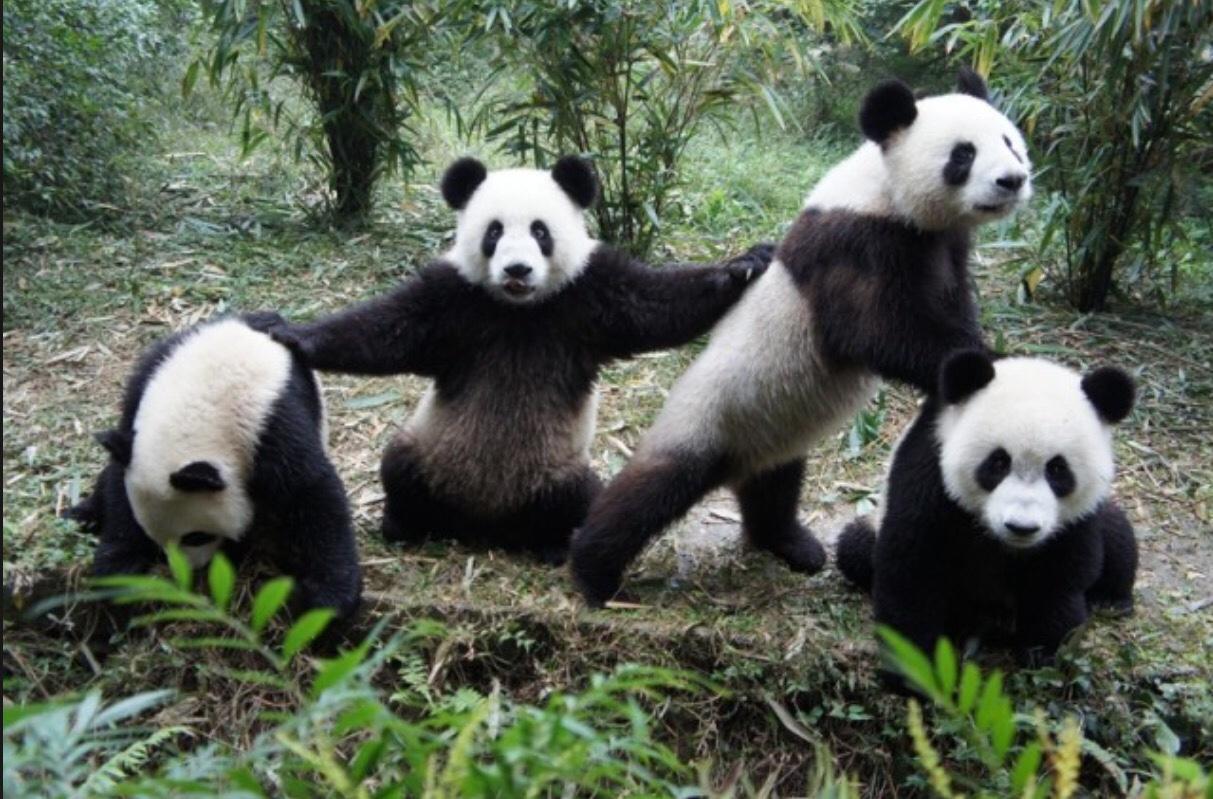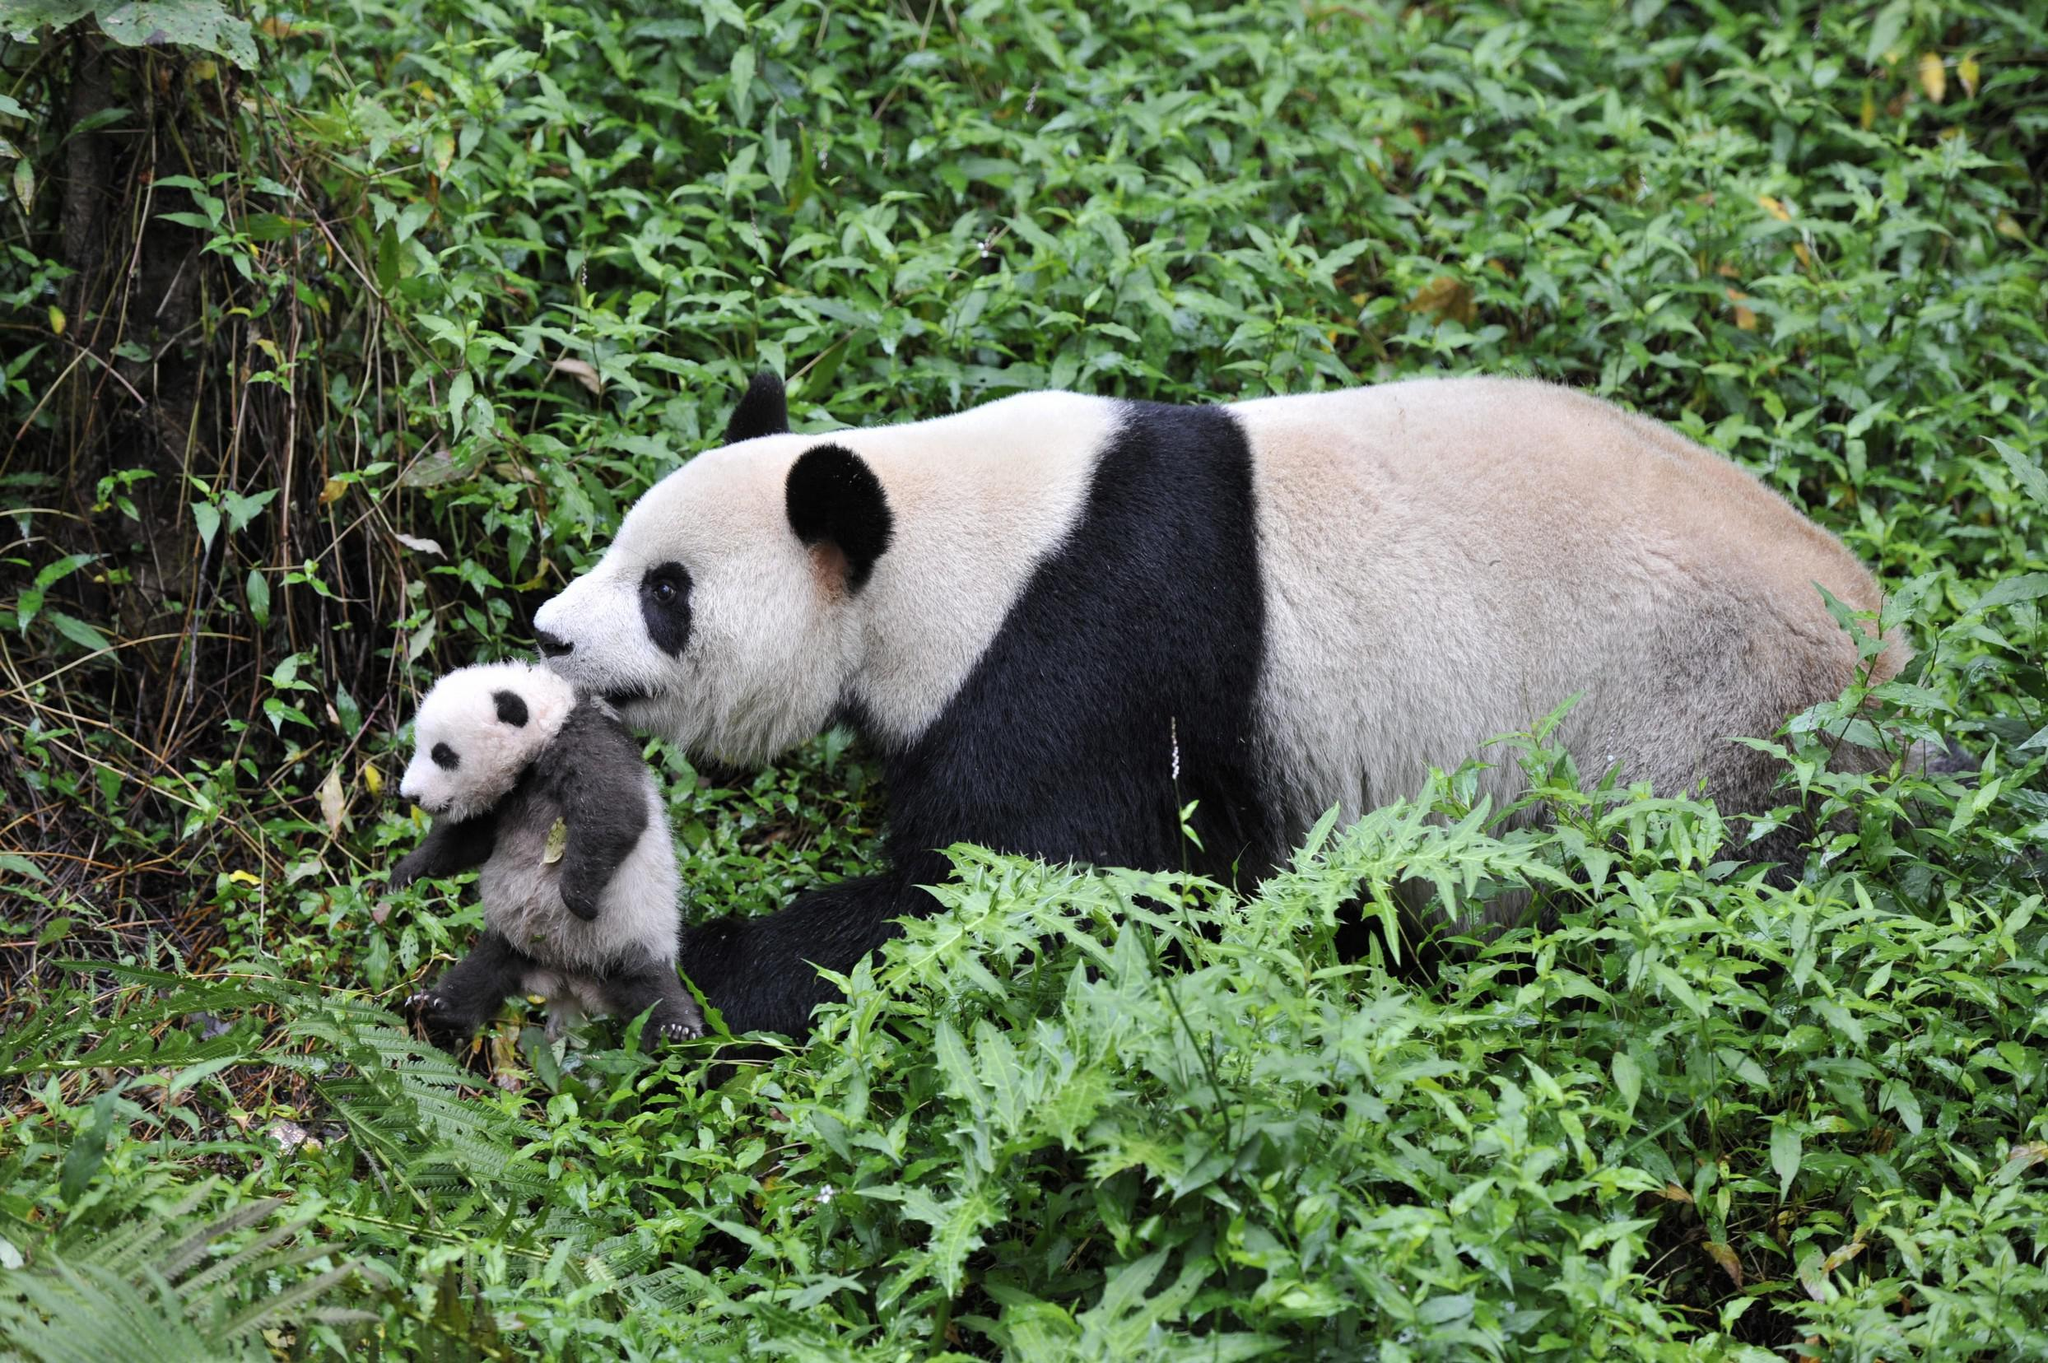The first image is the image on the left, the second image is the image on the right. Analyze the images presented: Is the assertion "An image shows two pandas who appear to be playfully wrestling." valid? Answer yes or no. No. The first image is the image on the left, the second image is the image on the right. Evaluate the accuracy of this statement regarding the images: "there are  exactly four pandas in one of the images". Is it true? Answer yes or no. Yes. 